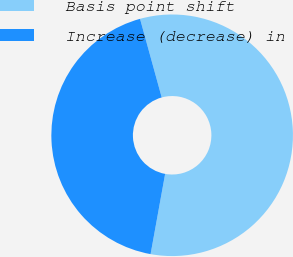<chart> <loc_0><loc_0><loc_500><loc_500><pie_chart><fcel>Basis point shift<fcel>Increase (decrease) in<nl><fcel>57.14%<fcel>42.86%<nl></chart> 